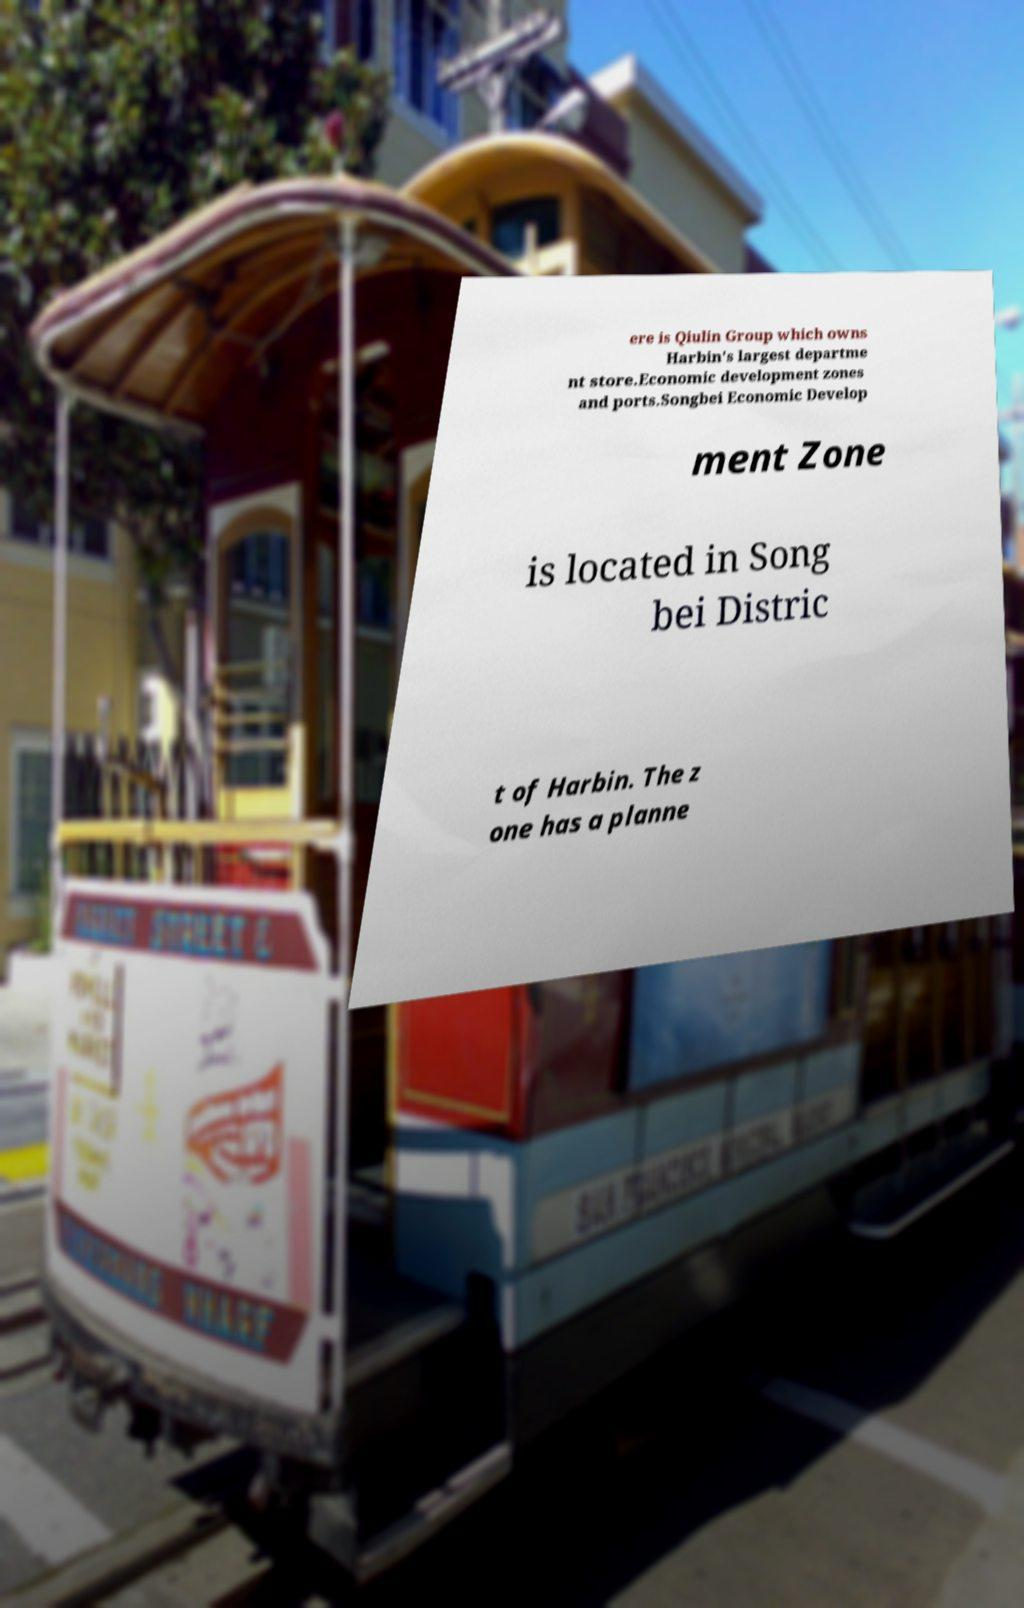There's text embedded in this image that I need extracted. Can you transcribe it verbatim? ere is Qiulin Group which owns Harbin's largest departme nt store.Economic development zones and ports.Songbei Economic Develop ment Zone is located in Song bei Distric t of Harbin. The z one has a planne 